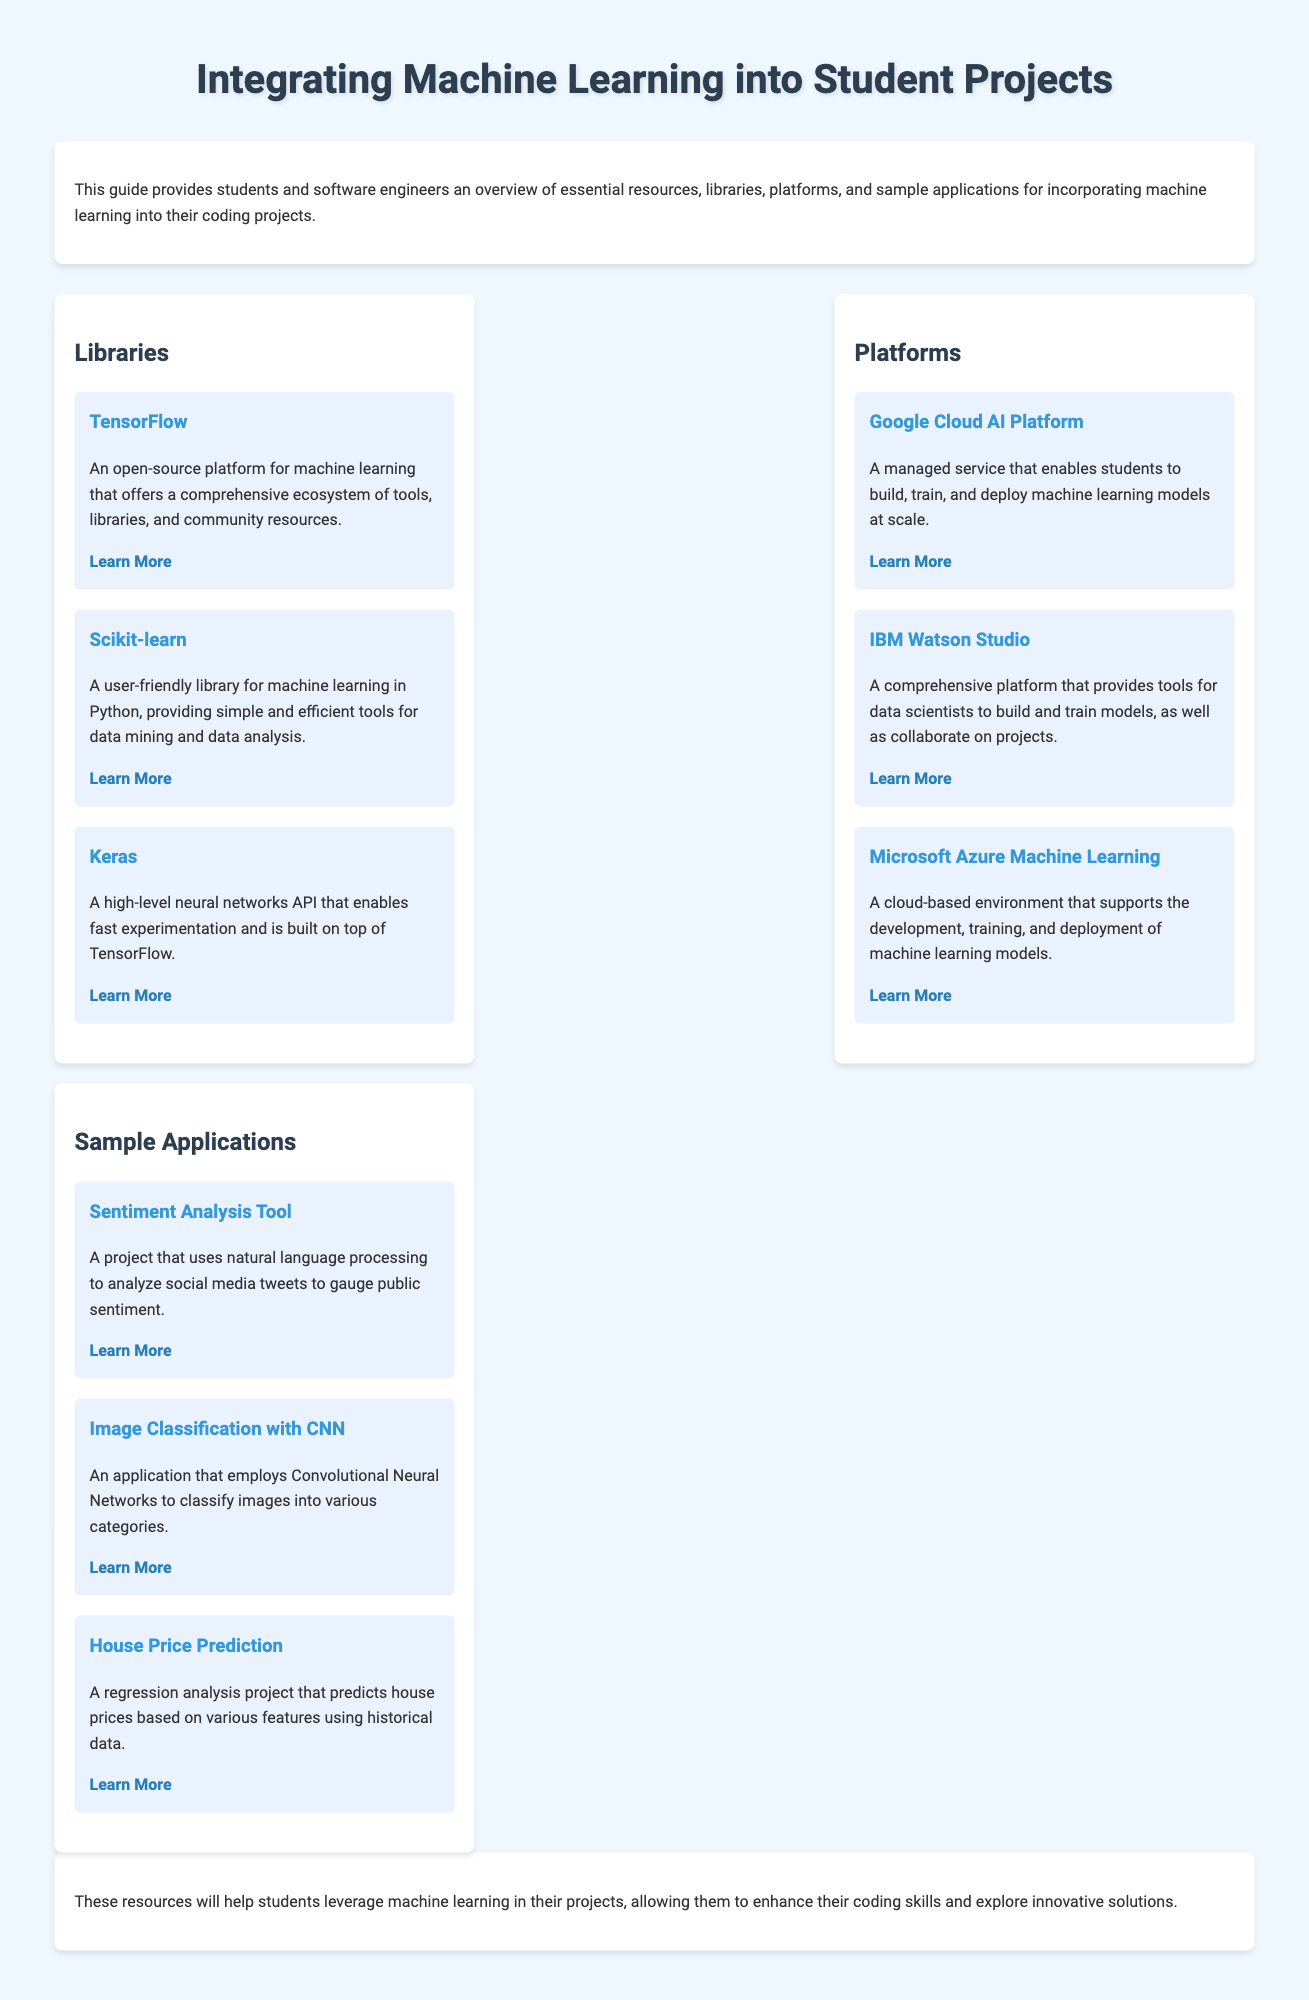What is the title of the document? The document's title is presented prominently in the header section.
Answer: Integrating Machine Learning into Student Projects How many libraries are listed in the document? The section on libraries contains three entries.
Answer: 3 What is the name of the platform that offers a managed service for machine learning? The platform is mentioned in the section under Platforms, which describes a service for building and deploying models.
Answer: Google Cloud AI Platform Which library is described as a user-friendly option for machine learning in Python? This information is found in the Libraries section, discussing the ease of use of the library.
Answer: Scikit-learn What kind of project is the Sentiment Analysis Tool focused on? The description specifies that the project analyzes social media tweets for public sentiment.
Answer: Natural language processing How many sample applications does the document provide? The section on sample applications lists three different projects.
Answer: 3 What is Keras built on top of? The document states that Keras is a high-level API built on top of another library.
Answer: TensorFlow Which platform provides tools for collaboration on machine learning projects? The description for the platform indicates it is designed for collaboration among data scientists.
Answer: IBM Watson Studio What is the target audience of this guide? The introduction of the document clearly states the intended users of the guide.
Answer: Students and software engineers 